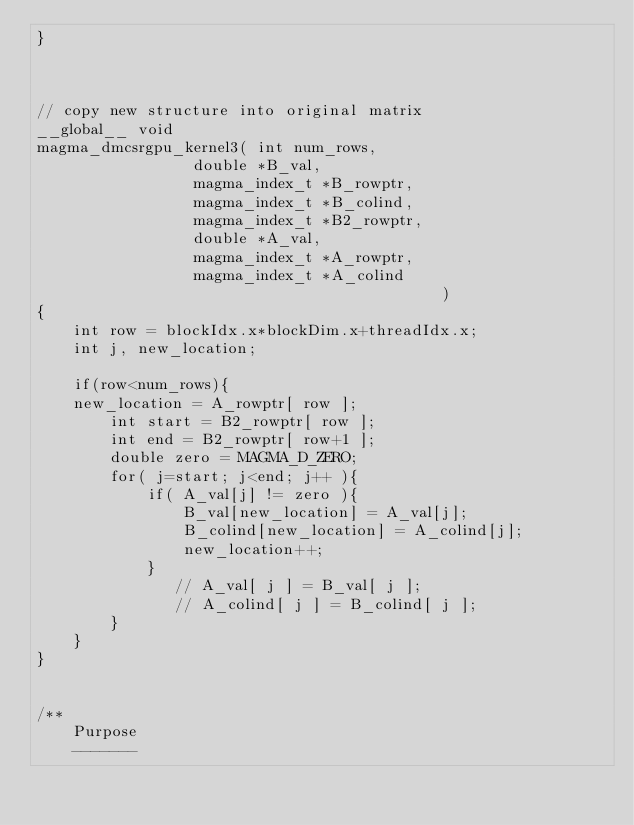<code> <loc_0><loc_0><loc_500><loc_500><_Cuda_>}



// copy new structure into original matrix
__global__ void
magma_dmcsrgpu_kernel3( int num_rows,
                 double *B_val,
                 magma_index_t *B_rowptr,
                 magma_index_t *B_colind,
                 magma_index_t *B2_rowptr,
                 double *A_val,
                 magma_index_t *A_rowptr,
                 magma_index_t *A_colind
                                            )
{
    int row = blockIdx.x*blockDim.x+threadIdx.x;
    int j, new_location;
    
    if(row<num_rows){
    new_location = A_rowptr[ row ];
        int start = B2_rowptr[ row ];
        int end = B2_rowptr[ row+1 ];
        double zero = MAGMA_D_ZERO;
        for( j=start; j<end; j++ ){
            if( A_val[j] != zero ){
                B_val[new_location] = A_val[j];
                B_colind[new_location] = A_colind[j];
                new_location++;
            }
               // A_val[ j ] = B_val[ j ];
               // A_colind[ j ] = B_colind[ j ];
        }
    }
}


/**
    Purpose
    -------
</code> 